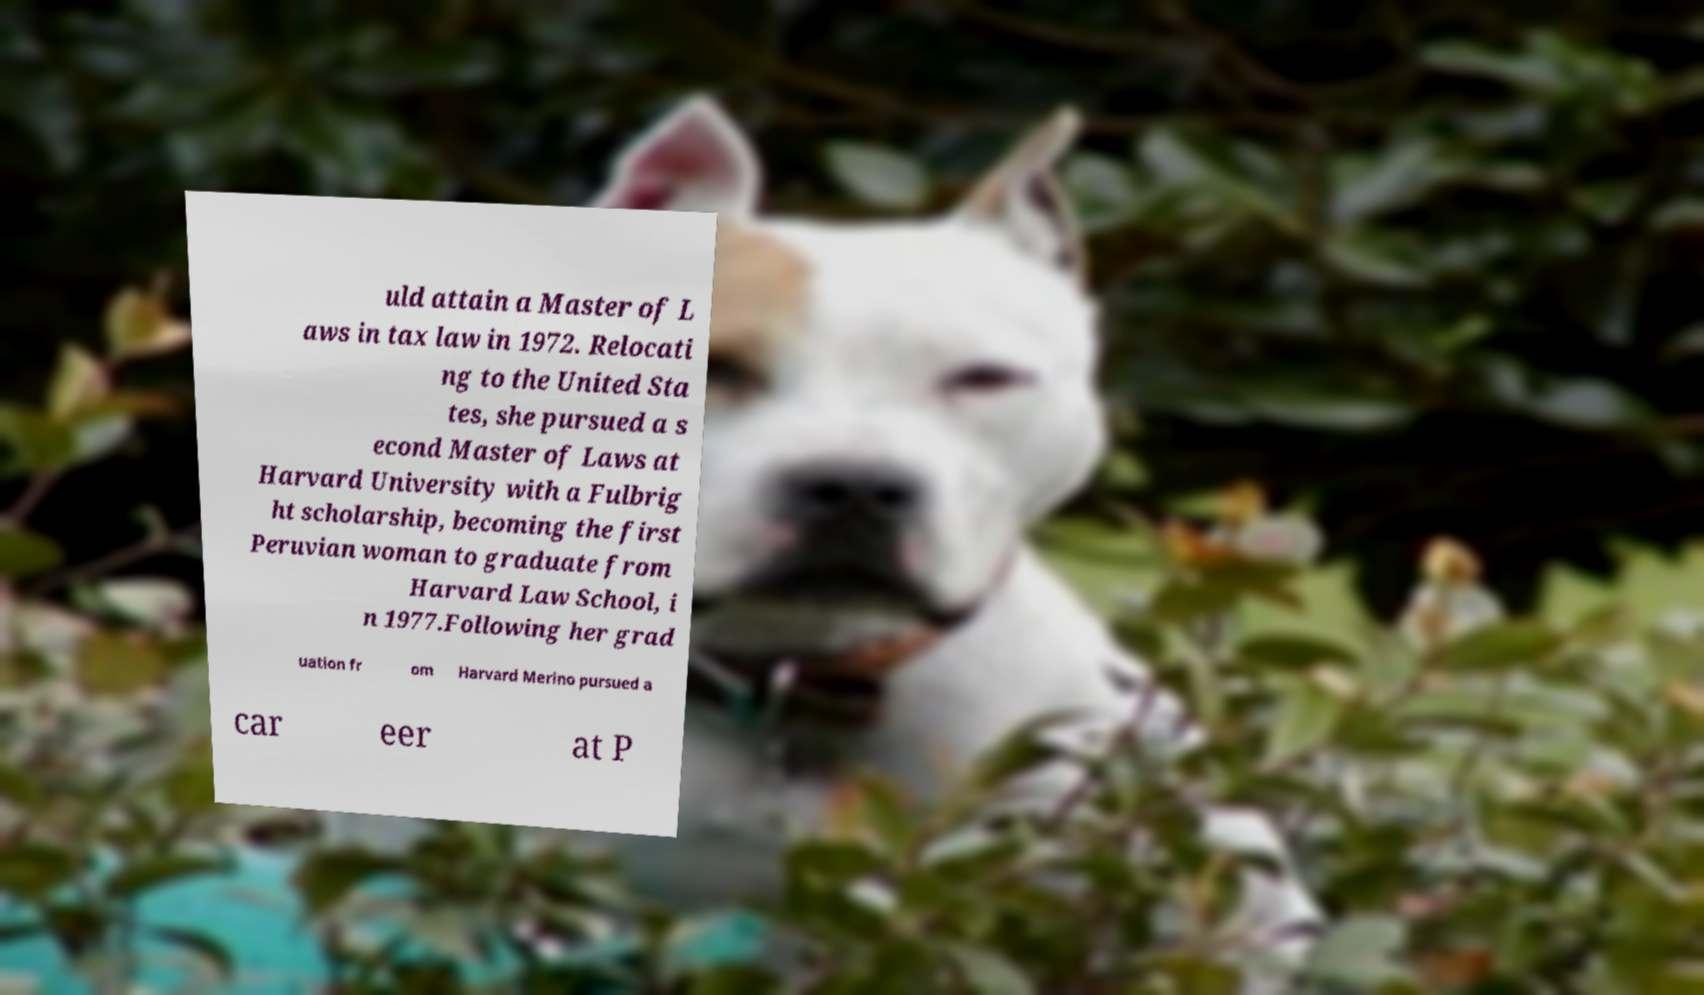Please read and relay the text visible in this image. What does it say? uld attain a Master of L aws in tax law in 1972. Relocati ng to the United Sta tes, she pursued a s econd Master of Laws at Harvard University with a Fulbrig ht scholarship, becoming the first Peruvian woman to graduate from Harvard Law School, i n 1977.Following her grad uation fr om Harvard Merino pursued a car eer at P 